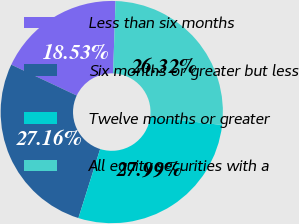Convert chart. <chart><loc_0><loc_0><loc_500><loc_500><pie_chart><fcel>Less than six months<fcel>Six months or greater but less<fcel>Twelve months or greater<fcel>All equity securities with a<nl><fcel>18.53%<fcel>27.16%<fcel>27.99%<fcel>26.32%<nl></chart> 